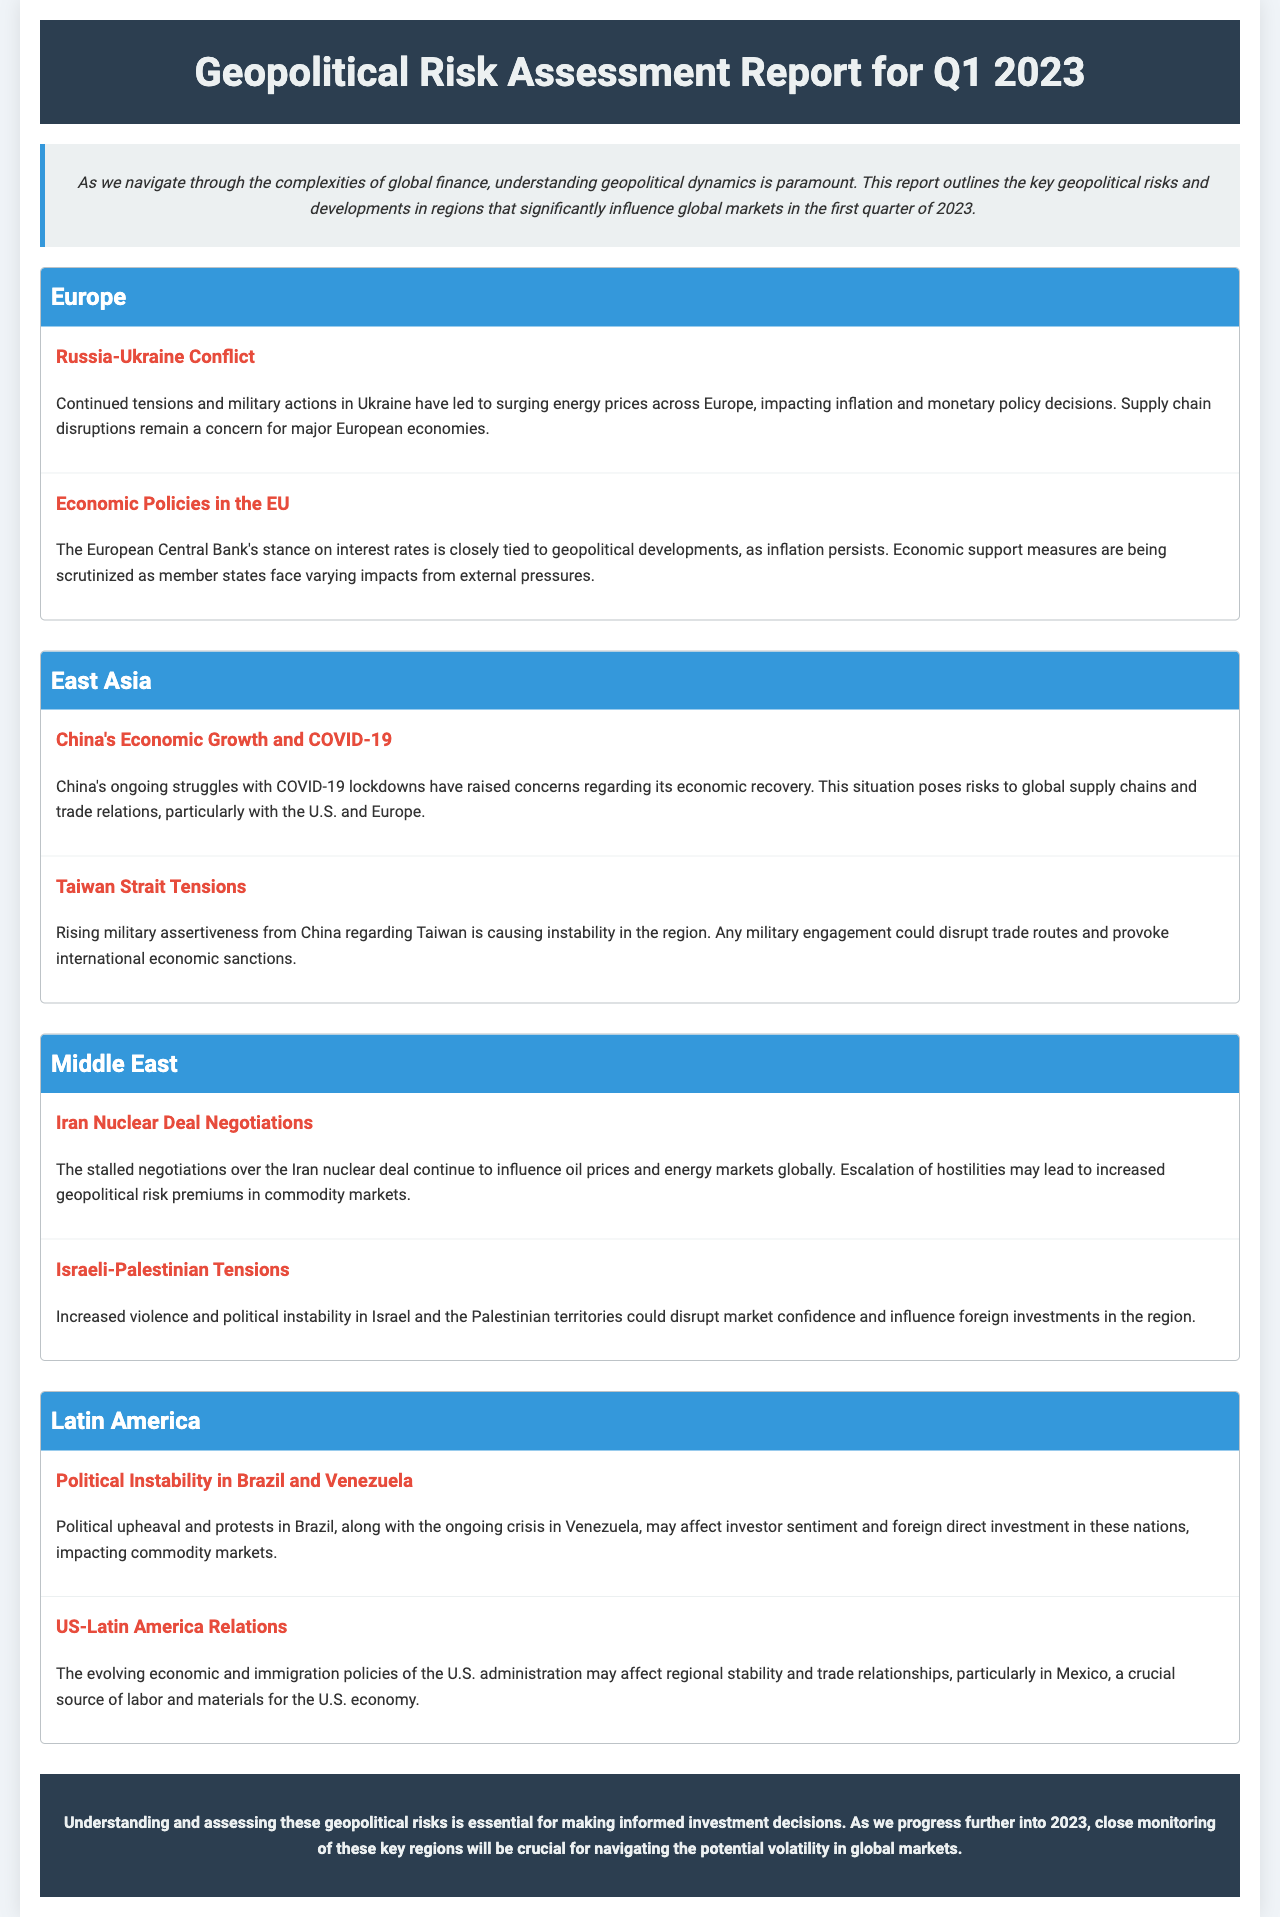What are the two main geopolitical regions discussed? The document highlights key geopolitical risks and developments in several regions, specifically Europe and East Asia.
Answer: Europe, East Asia What conflict is causing energy prices to surge in Europe? The document states that the continued tensions and military actions in Ukraine, specifically the Russia-Ukraine conflict, have affected energy prices in Europe.
Answer: Russia-Ukraine Conflict Which Middle Eastern issues are influencing oil prices? The report mentions the stalled negotiations over the Iran nuclear deal as having a significant impact on oil prices and energy markets.
Answer: Iran Nuclear Deal Negotiations What is the ongoing economic challenge in China? The document indicates that China's struggles with COVID-19 lockdowns are a major challenge affecting its economic recovery.
Answer: COVID-19 Which region's political instability affects investor sentiment and foreign direct investment? The document notes that political upheaval and protests in Brazil, and the ongoing crisis in Venezuela are impacting these factors in Latin America.
Answer: Latin America What is the primary concern related to Taiwan in East Asia? The document highlights rising military assertiveness from China regarding Taiwan as a region of increasing instability and concern.
Answer: Taiwan Strait Tensions What is the impact of the U.S. administration's policies on Latin America? The document states that the evolving economic and immigration policies of the U.S. administration may affect regional stability and trade relationships in Latin America.
Answer: Trade relationships What is the document's conclusion about assessing geopolitical risks? It emphasizes the necessity of understanding and monitoring geopolitical risks for making informed investment decisions.
Answer: Essential for informed investment decisions 